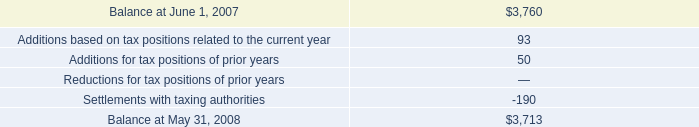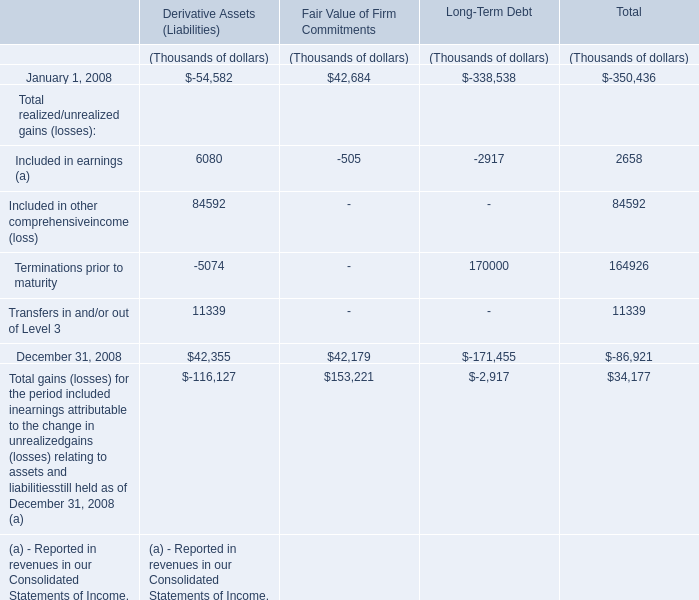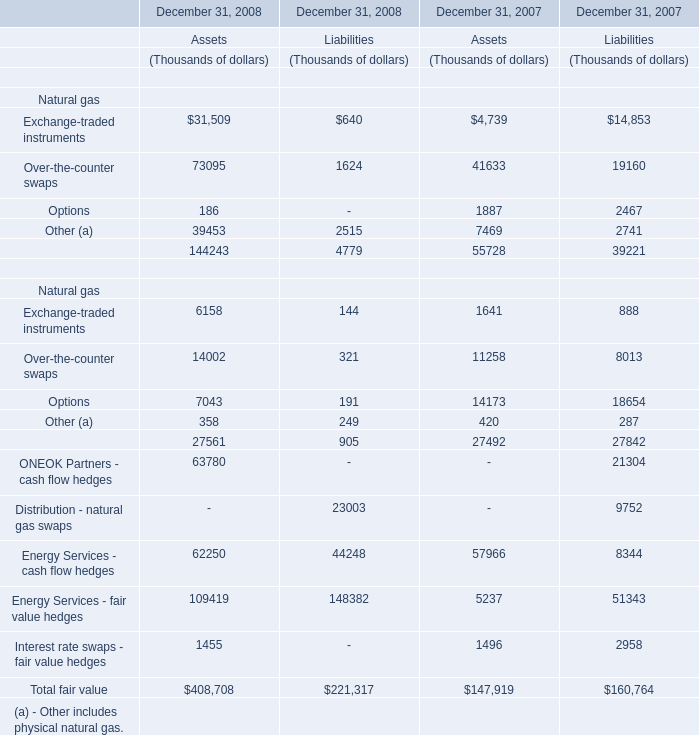What is the ratio of all Derivative Assets (Liabilities) that are smaller than 0 to the sum of Derivative Assets (Liabilities) in 2008? 
Computations: (((-54582 - 5074) - 116127) / ((((((-54582 - 5074) - 116127) + 6080) + 84592) + 11339) + 42355))
Answer: 5.59516. 